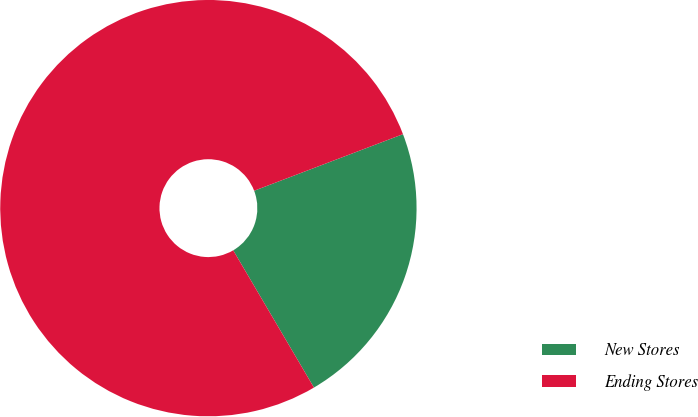Convert chart. <chart><loc_0><loc_0><loc_500><loc_500><pie_chart><fcel>New Stores<fcel>Ending Stores<nl><fcel>22.32%<fcel>77.68%<nl></chart> 